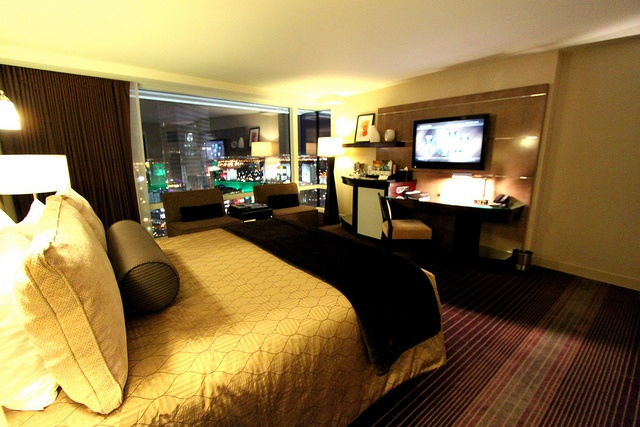Describe the objects in this image and their specific colors. I can see bed in khaki, black, gold, orange, and maroon tones, tv in khaki, white, black, darkgray, and lightblue tones, chair in khaki, black, maroon, and olive tones, chair in khaki, black, maroon, and olive tones, and chair in khaki, black, maroon, and olive tones in this image. 